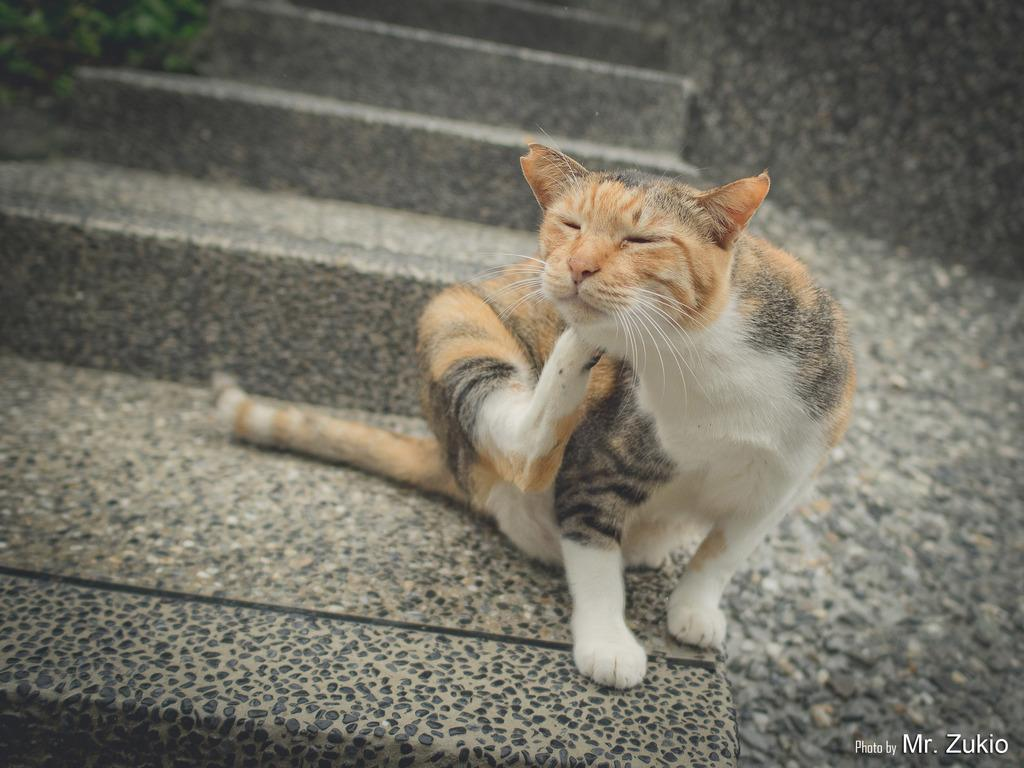What type of animal is in the image? There is a cat in the image. What is the cat doing in the image? The cat is sitting and itching with one of its legs. Is there any text present in the image? Yes, there is text written in the right bottom corner of the image. Can you tell me how many times the cat has twisted its body in the image? There is no indication in the image that the cat has twisted its body, so it cannot be determined from the picture. 